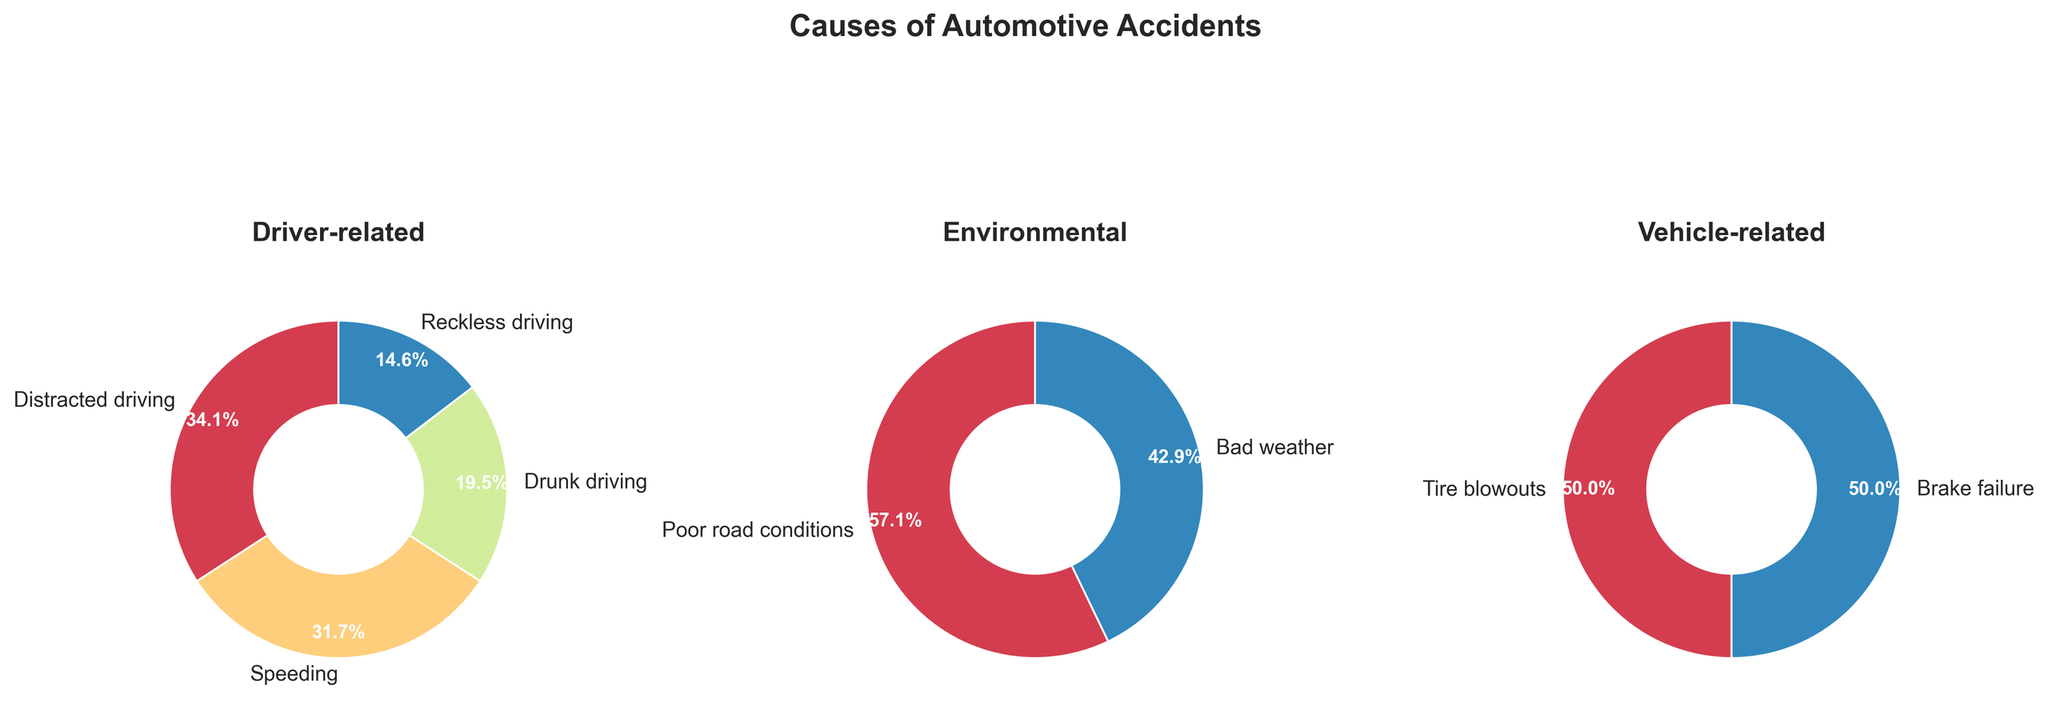What is the title of the plot? The title of the plot is written at the top of the figure.
Answer: Causes of Automotive Accidents How many main categories of contributing factors are there? The plot is divided into subplots, each with a title representing a category. Counting these titles gives the number of main categories.
Answer: 3 Which driver-related factor has the highest percentage? In the pie chart titled "Driver-related," the slice with the largest percentage value represents the factor with the highest percentage.
Answer: Distracted driving What is the combined percentage of driver-related factors? Add the percentages of all factors under the "Driver-related" category: 28 (Distracted driving) + 26 (Speeding) + 16 (Drunk driving) + 12 (Reckless driving) = 82%.
Answer: 82% Is the percentage of brake failure equal to the percentage of tire blowouts? By looking at the "Vehicle-related" pie chart, compare the percentages listed for brake failure and tire blowouts.
Answer: Yes How does bad weather's percentage compare to poor road conditions? Compare the percentage value of "Bad weather" and "Poor road conditions" within the "Environmental" pie chart.
Answer: Bad weather is 2% less than poor road conditions What percentage of the total do environmental factors contribute? Add the percentages of the factors in the "Environmental" category: 8 (Poor road conditions) + 6 (Bad weather) = 14%.
Answer: 14% Which category has the least number of factors? By counting the number of slices in each pie chart, identify the one with the fewest slices.
Answer: Vehicle-related How many percentage points greater is distracted driving than drunk driving? Subtract the percentage of "Drunk driving" from the percentage of "Distracted driving": 28 - 16 = 12 percentage points.
Answer: 12 percentage points Based on the pie charts, which factor related to vehicles has the same percentage? The "Vehicle-related" pie chart shows both "Tire blowouts" and "Brake failure" have the same percentage values.
Answer: Tire blowouts and Brake failure 